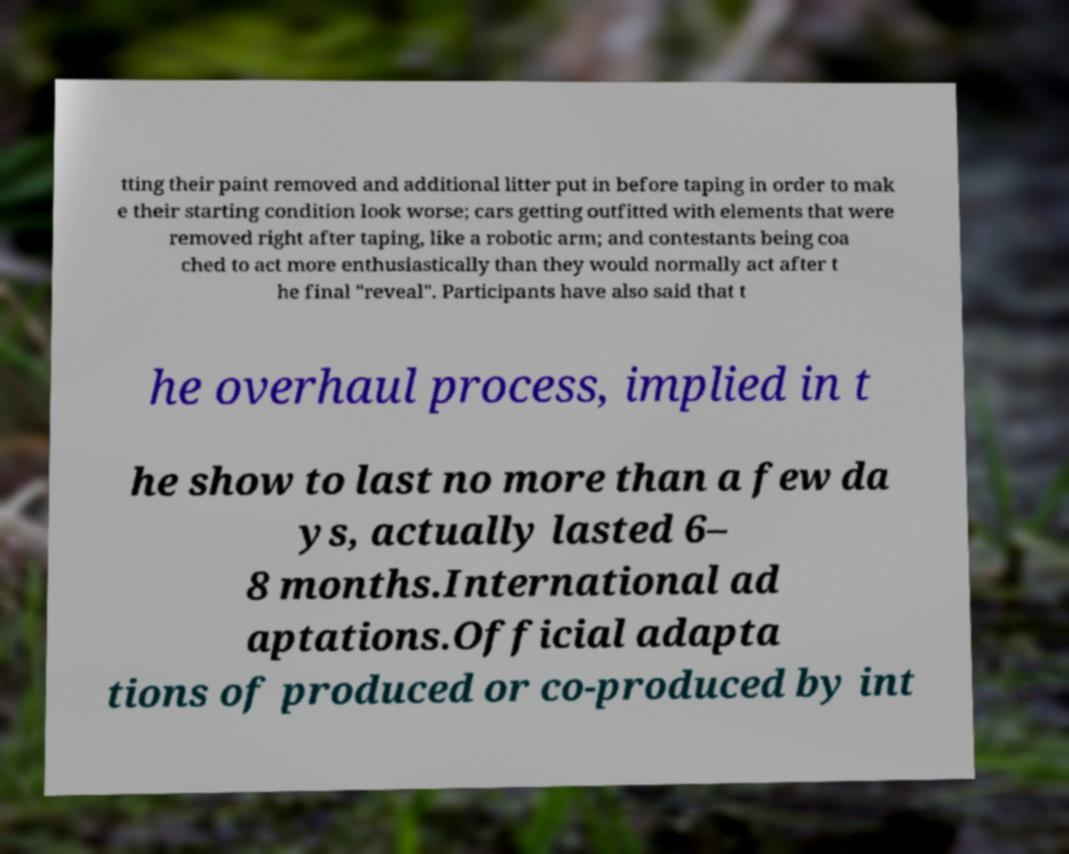Please identify and transcribe the text found in this image. tting their paint removed and additional litter put in before taping in order to mak e their starting condition look worse; cars getting outfitted with elements that were removed right after taping, like a robotic arm; and contestants being coa ched to act more enthusiastically than they would normally act after t he final "reveal". Participants have also said that t he overhaul process, implied in t he show to last no more than a few da ys, actually lasted 6– 8 months.International ad aptations.Official adapta tions of produced or co-produced by int 